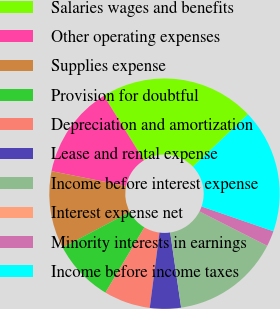<chart> <loc_0><loc_0><loc_500><loc_500><pie_chart><fcel>Salaries wages and benefits<fcel>Other operating expenses<fcel>Supplies expense<fcel>Provision for doubtful<fcel>Depreciation and amortization<fcel>Lease and rental expense<fcel>Income before interest expense<fcel>Interest expense net<fcel>Minority interests in earnings<fcel>Income before income taxes<nl><fcel>21.73%<fcel>13.04%<fcel>10.87%<fcel>8.7%<fcel>6.52%<fcel>4.35%<fcel>15.21%<fcel>0.01%<fcel>2.18%<fcel>17.38%<nl></chart> 